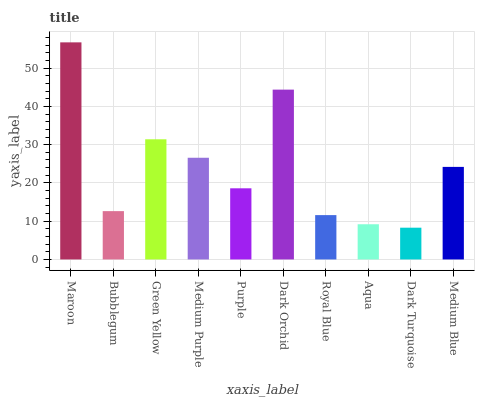Is Bubblegum the minimum?
Answer yes or no. No. Is Bubblegum the maximum?
Answer yes or no. No. Is Maroon greater than Bubblegum?
Answer yes or no. Yes. Is Bubblegum less than Maroon?
Answer yes or no. Yes. Is Bubblegum greater than Maroon?
Answer yes or no. No. Is Maroon less than Bubblegum?
Answer yes or no. No. Is Medium Blue the high median?
Answer yes or no. Yes. Is Purple the low median?
Answer yes or no. Yes. Is Aqua the high median?
Answer yes or no. No. Is Medium Purple the low median?
Answer yes or no. No. 